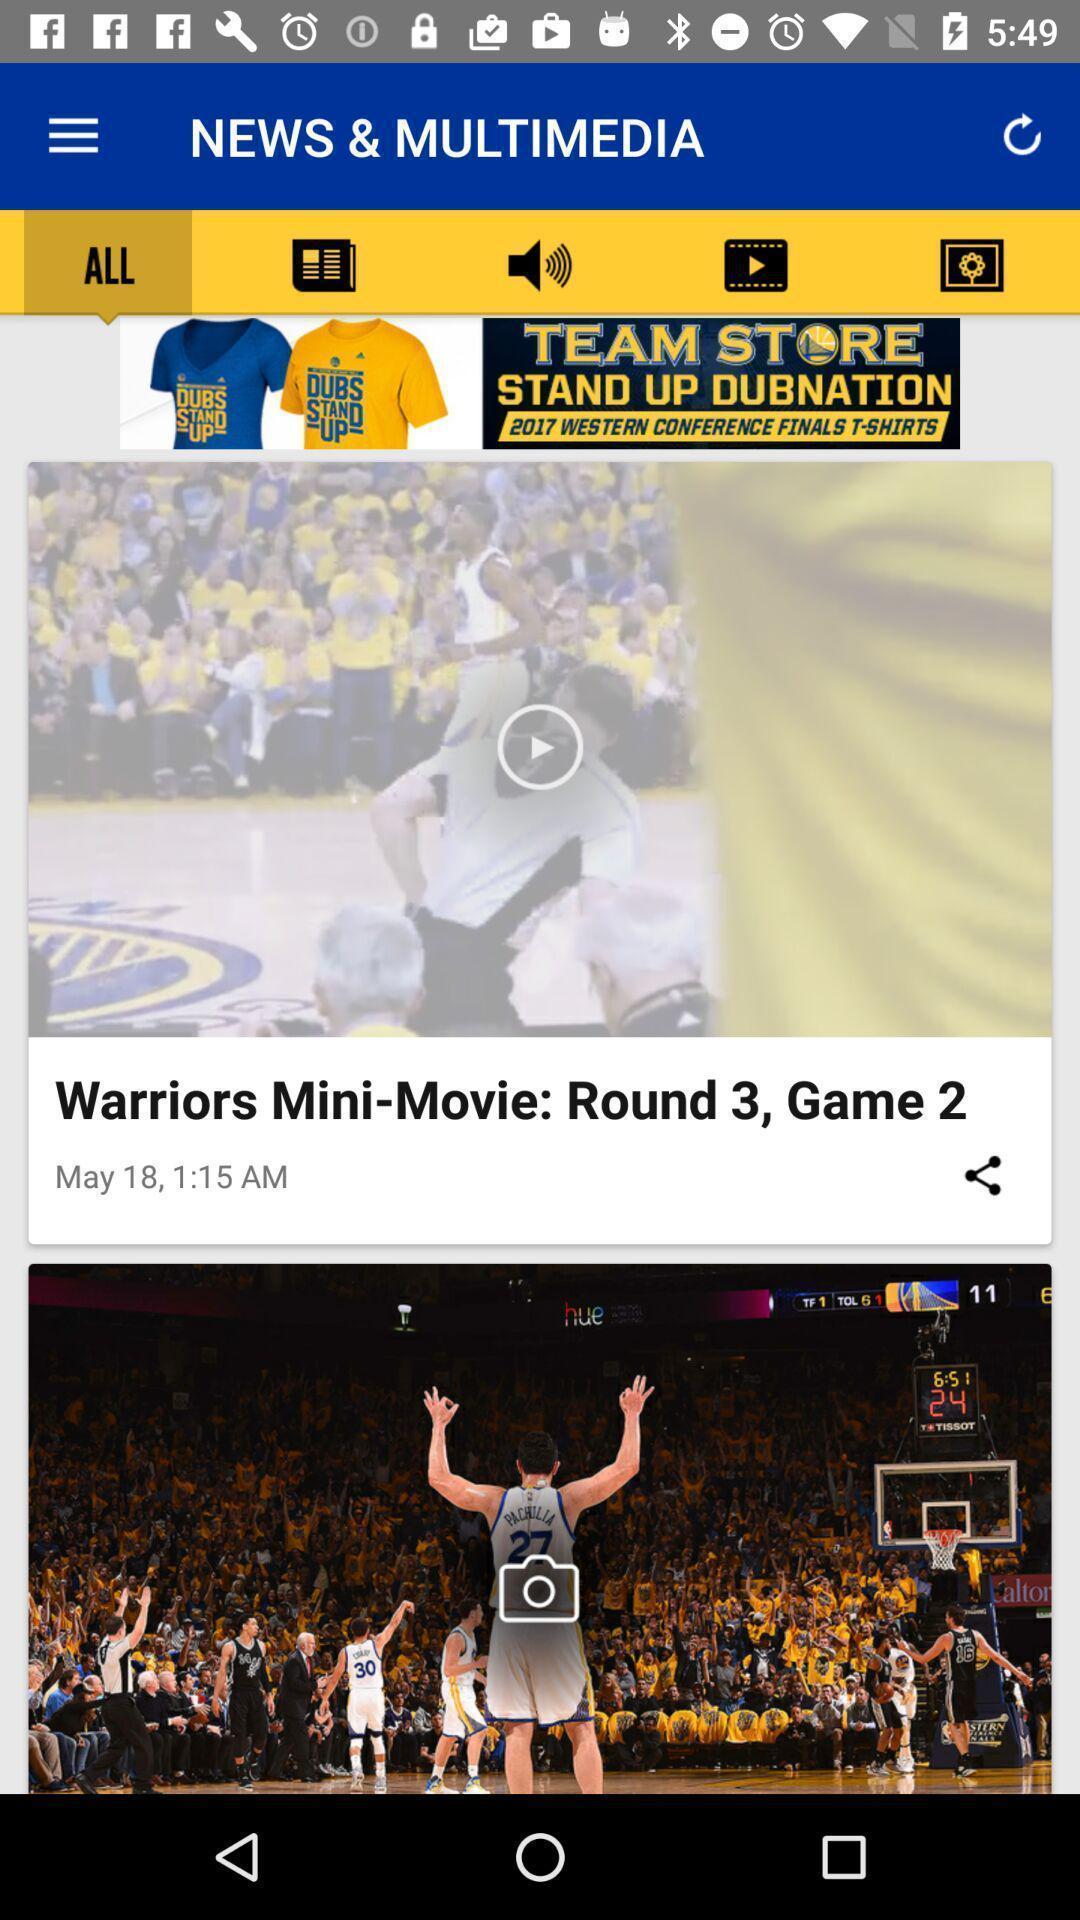Provide a textual representation of this image. Screen showing new page. 